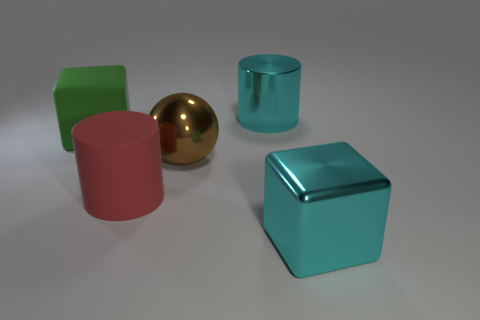There is another object that is the same shape as the green object; what material is it?
Your answer should be very brief. Metal. Is the color of the big metallic cylinder the same as the shiny cube?
Your answer should be very brief. Yes. What number of brown objects are on the left side of the cylinder in front of the big green object?
Your response must be concise. 0. What size is the object that is left of the large brown shiny ball and behind the big red object?
Provide a short and direct response. Large. What is the cylinder in front of the green rubber object made of?
Provide a short and direct response. Rubber. Is there a purple object that has the same shape as the green thing?
Make the answer very short. No. How many large green things have the same shape as the red thing?
Provide a succinct answer. 0. Does the cyan metallic object that is in front of the big matte cube have the same size as the cyan metallic thing behind the large cyan block?
Offer a very short reply. Yes. There is a cyan shiny object right of the large cyan shiny object behind the brown ball; what shape is it?
Give a very brief answer. Cube. Are there the same number of brown shiny objects that are on the right side of the brown shiny thing and tiny blue shiny objects?
Give a very brief answer. Yes. 